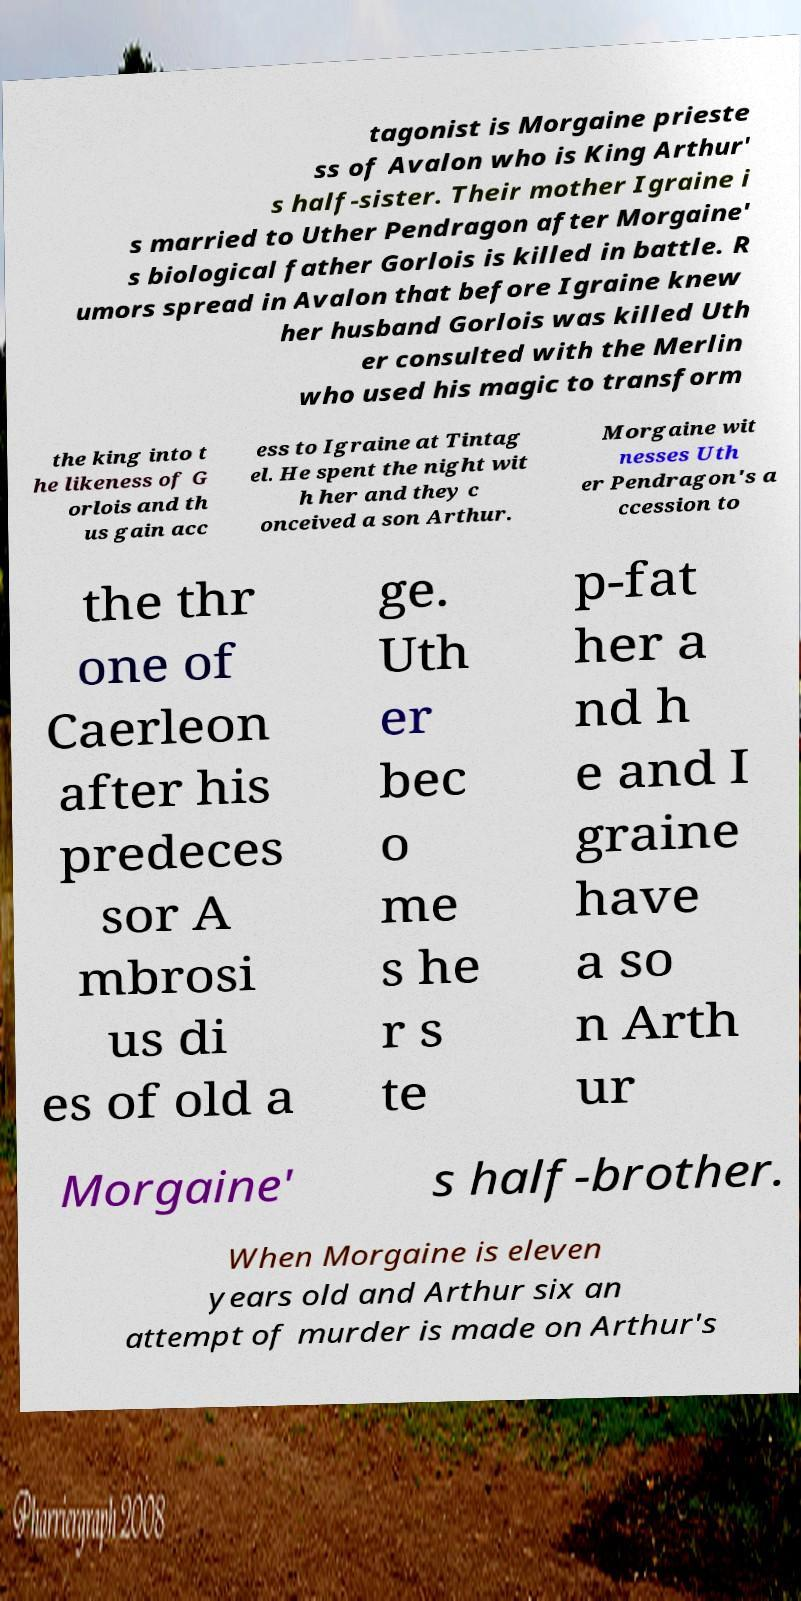Please identify and transcribe the text found in this image. tagonist is Morgaine prieste ss of Avalon who is King Arthur' s half-sister. Their mother Igraine i s married to Uther Pendragon after Morgaine' s biological father Gorlois is killed in battle. R umors spread in Avalon that before Igraine knew her husband Gorlois was killed Uth er consulted with the Merlin who used his magic to transform the king into t he likeness of G orlois and th us gain acc ess to Igraine at Tintag el. He spent the night wit h her and they c onceived a son Arthur. Morgaine wit nesses Uth er Pendragon's a ccession to the thr one of Caerleon after his predeces sor A mbrosi us di es of old a ge. Uth er bec o me s he r s te p-fat her a nd h e and I graine have a so n Arth ur Morgaine' s half-brother. When Morgaine is eleven years old and Arthur six an attempt of murder is made on Arthur's 